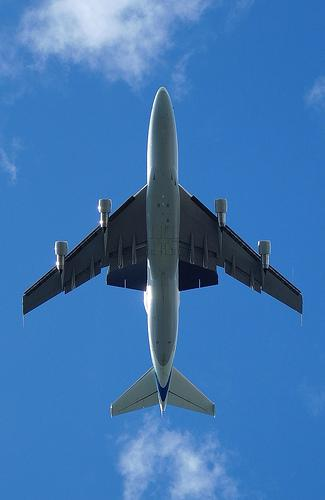Question: why is the underside of the plane shown?
Choices:
A. It's being inspected.
B. It's taking off.
C. It's turned upside-down.
D. It's being built.
Answer with the letter. Answer: B Question: what does the sky look like?
Choices:
A. Grey.
B. Blue.
C. Yellow.
D. Black.
Answer with the letter. Answer: B Question: when is the picture taken?
Choices:
A. At nighttime.
B. At daytime.
C. On the weekend.
D. On a weekday.
Answer with the letter. Answer: B Question: what is behind the plane?
Choices:
A. Ice crystals.
B. Sky.
C. The departure location.
D. Exhaust.
Answer with the letter. Answer: D Question: where are the engines located?
Choices:
A. Under the hood.
B. Under the wings.
C. On the sides.
D. At the front.
Answer with the letter. Answer: B 